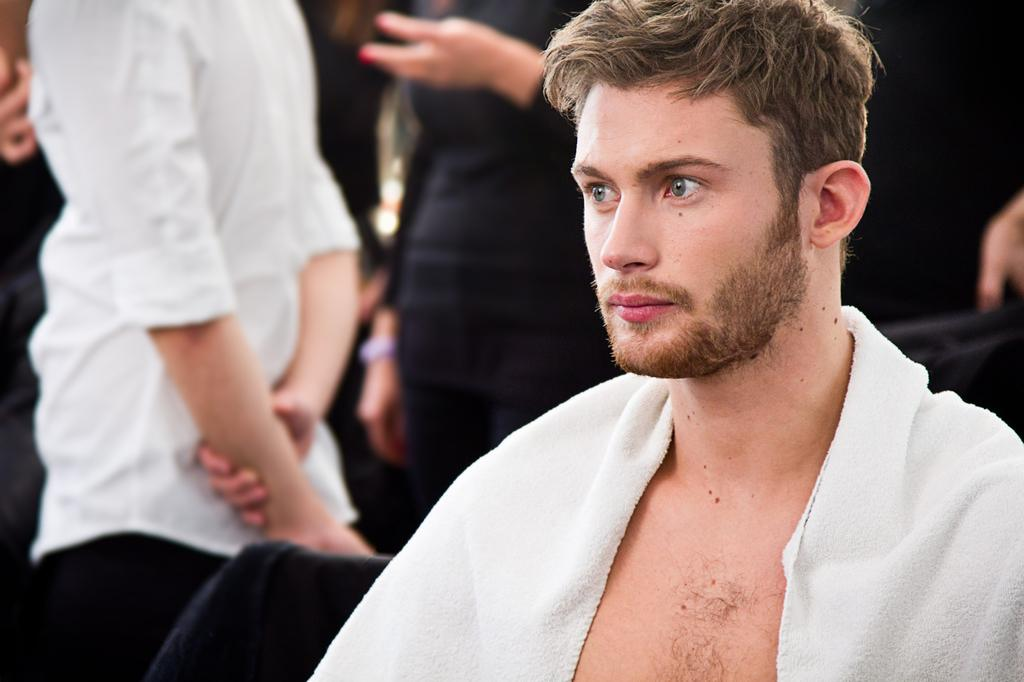What is the main subject in the foreground of the image? There is a man sitting in the foreground of the image. What can be seen in the background of the image? There are people standing in the background of the image. What type of furniture is visible in the image? There are chairs visible in the image. What type of stamp can be seen on the man's forehead in the image? There is no stamp visible on the man's forehead in the image. 